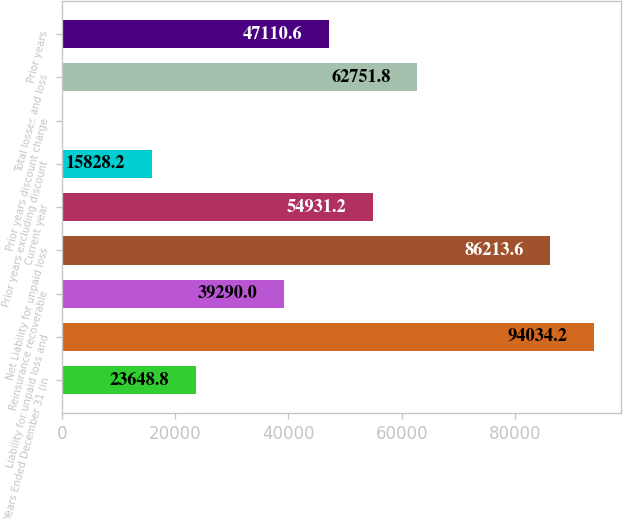<chart> <loc_0><loc_0><loc_500><loc_500><bar_chart><fcel>Years Ended December 31 (in<fcel>Liability for unpaid loss and<fcel>Reinsurance recoverable<fcel>Net Liability for unpaid loss<fcel>Current year<fcel>Prior years excluding discount<fcel>Prior years discount charge<fcel>Total losses and loss<fcel>Prior years<nl><fcel>23648.8<fcel>94034.2<fcel>39290<fcel>86213.6<fcel>54931.2<fcel>15828.2<fcel>187<fcel>62751.8<fcel>47110.6<nl></chart> 